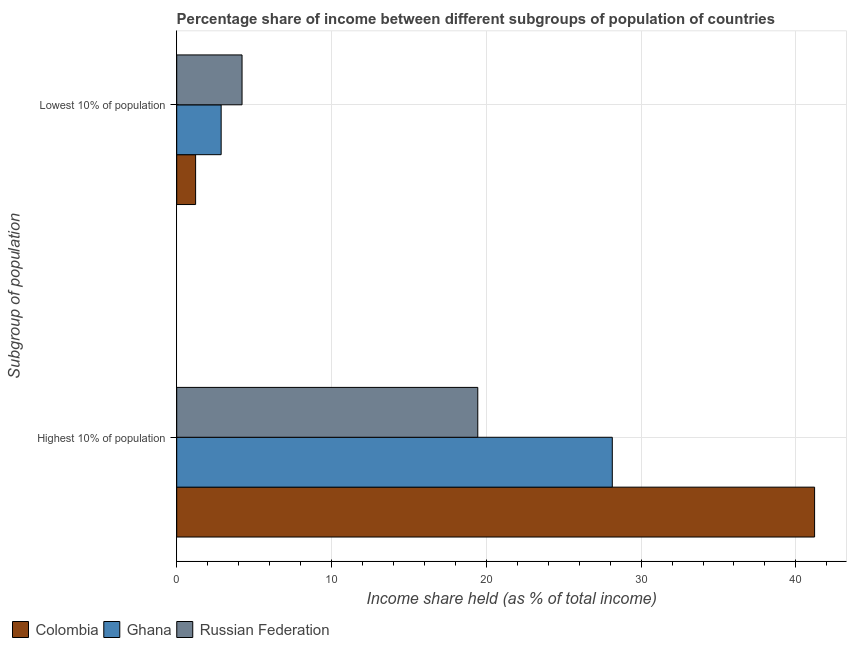How many groups of bars are there?
Provide a short and direct response. 2. Are the number of bars on each tick of the Y-axis equal?
Keep it short and to the point. Yes. How many bars are there on the 1st tick from the top?
Make the answer very short. 3. What is the label of the 2nd group of bars from the top?
Keep it short and to the point. Highest 10% of population. What is the income share held by lowest 10% of the population in Russian Federation?
Make the answer very short. 4.22. Across all countries, what is the maximum income share held by highest 10% of the population?
Provide a succinct answer. 41.21. Across all countries, what is the minimum income share held by lowest 10% of the population?
Provide a short and direct response. 1.22. In which country was the income share held by lowest 10% of the population maximum?
Ensure brevity in your answer.  Russian Federation. In which country was the income share held by highest 10% of the population minimum?
Provide a succinct answer. Russian Federation. What is the total income share held by highest 10% of the population in the graph?
Your answer should be compact. 88.8. What is the difference between the income share held by highest 10% of the population in Russian Federation and that in Colombia?
Your answer should be very brief. -21.76. What is the difference between the income share held by highest 10% of the population in Russian Federation and the income share held by lowest 10% of the population in Colombia?
Make the answer very short. 18.23. What is the average income share held by highest 10% of the population per country?
Keep it short and to the point. 29.6. What is the difference between the income share held by highest 10% of the population and income share held by lowest 10% of the population in Russian Federation?
Your answer should be very brief. 15.23. What is the ratio of the income share held by lowest 10% of the population in Russian Federation to that in Ghana?
Ensure brevity in your answer.  1.47. Are all the bars in the graph horizontal?
Provide a short and direct response. Yes. What is the difference between two consecutive major ticks on the X-axis?
Your answer should be very brief. 10. Are the values on the major ticks of X-axis written in scientific E-notation?
Keep it short and to the point. No. Does the graph contain grids?
Provide a succinct answer. Yes. Where does the legend appear in the graph?
Your answer should be compact. Bottom left. How are the legend labels stacked?
Provide a short and direct response. Horizontal. What is the title of the graph?
Your answer should be compact. Percentage share of income between different subgroups of population of countries. What is the label or title of the X-axis?
Your response must be concise. Income share held (as % of total income). What is the label or title of the Y-axis?
Ensure brevity in your answer.  Subgroup of population. What is the Income share held (as % of total income) in Colombia in Highest 10% of population?
Offer a terse response. 41.21. What is the Income share held (as % of total income) in Ghana in Highest 10% of population?
Your answer should be compact. 28.14. What is the Income share held (as % of total income) in Russian Federation in Highest 10% of population?
Make the answer very short. 19.45. What is the Income share held (as % of total income) of Colombia in Lowest 10% of population?
Your answer should be very brief. 1.22. What is the Income share held (as % of total income) of Ghana in Lowest 10% of population?
Make the answer very short. 2.87. What is the Income share held (as % of total income) of Russian Federation in Lowest 10% of population?
Offer a very short reply. 4.22. Across all Subgroup of population, what is the maximum Income share held (as % of total income) of Colombia?
Provide a succinct answer. 41.21. Across all Subgroup of population, what is the maximum Income share held (as % of total income) of Ghana?
Offer a terse response. 28.14. Across all Subgroup of population, what is the maximum Income share held (as % of total income) in Russian Federation?
Your answer should be very brief. 19.45. Across all Subgroup of population, what is the minimum Income share held (as % of total income) of Colombia?
Offer a terse response. 1.22. Across all Subgroup of population, what is the minimum Income share held (as % of total income) of Ghana?
Offer a terse response. 2.87. Across all Subgroup of population, what is the minimum Income share held (as % of total income) in Russian Federation?
Ensure brevity in your answer.  4.22. What is the total Income share held (as % of total income) in Colombia in the graph?
Your answer should be very brief. 42.43. What is the total Income share held (as % of total income) of Ghana in the graph?
Ensure brevity in your answer.  31.01. What is the total Income share held (as % of total income) in Russian Federation in the graph?
Keep it short and to the point. 23.67. What is the difference between the Income share held (as % of total income) in Colombia in Highest 10% of population and that in Lowest 10% of population?
Provide a succinct answer. 39.99. What is the difference between the Income share held (as % of total income) of Ghana in Highest 10% of population and that in Lowest 10% of population?
Provide a short and direct response. 25.27. What is the difference between the Income share held (as % of total income) of Russian Federation in Highest 10% of population and that in Lowest 10% of population?
Your answer should be compact. 15.23. What is the difference between the Income share held (as % of total income) in Colombia in Highest 10% of population and the Income share held (as % of total income) in Ghana in Lowest 10% of population?
Ensure brevity in your answer.  38.34. What is the difference between the Income share held (as % of total income) of Colombia in Highest 10% of population and the Income share held (as % of total income) of Russian Federation in Lowest 10% of population?
Ensure brevity in your answer.  36.99. What is the difference between the Income share held (as % of total income) in Ghana in Highest 10% of population and the Income share held (as % of total income) in Russian Federation in Lowest 10% of population?
Your answer should be very brief. 23.92. What is the average Income share held (as % of total income) in Colombia per Subgroup of population?
Provide a succinct answer. 21.21. What is the average Income share held (as % of total income) of Ghana per Subgroup of population?
Your response must be concise. 15.51. What is the average Income share held (as % of total income) in Russian Federation per Subgroup of population?
Make the answer very short. 11.84. What is the difference between the Income share held (as % of total income) in Colombia and Income share held (as % of total income) in Ghana in Highest 10% of population?
Keep it short and to the point. 13.07. What is the difference between the Income share held (as % of total income) of Colombia and Income share held (as % of total income) of Russian Federation in Highest 10% of population?
Provide a short and direct response. 21.76. What is the difference between the Income share held (as % of total income) in Ghana and Income share held (as % of total income) in Russian Federation in Highest 10% of population?
Your answer should be compact. 8.69. What is the difference between the Income share held (as % of total income) of Colombia and Income share held (as % of total income) of Ghana in Lowest 10% of population?
Your response must be concise. -1.65. What is the difference between the Income share held (as % of total income) of Ghana and Income share held (as % of total income) of Russian Federation in Lowest 10% of population?
Offer a terse response. -1.35. What is the ratio of the Income share held (as % of total income) of Colombia in Highest 10% of population to that in Lowest 10% of population?
Provide a succinct answer. 33.78. What is the ratio of the Income share held (as % of total income) of Ghana in Highest 10% of population to that in Lowest 10% of population?
Your answer should be compact. 9.8. What is the ratio of the Income share held (as % of total income) in Russian Federation in Highest 10% of population to that in Lowest 10% of population?
Your response must be concise. 4.61. What is the difference between the highest and the second highest Income share held (as % of total income) of Colombia?
Offer a terse response. 39.99. What is the difference between the highest and the second highest Income share held (as % of total income) of Ghana?
Make the answer very short. 25.27. What is the difference between the highest and the second highest Income share held (as % of total income) in Russian Federation?
Give a very brief answer. 15.23. What is the difference between the highest and the lowest Income share held (as % of total income) in Colombia?
Ensure brevity in your answer.  39.99. What is the difference between the highest and the lowest Income share held (as % of total income) in Ghana?
Offer a very short reply. 25.27. What is the difference between the highest and the lowest Income share held (as % of total income) in Russian Federation?
Provide a short and direct response. 15.23. 